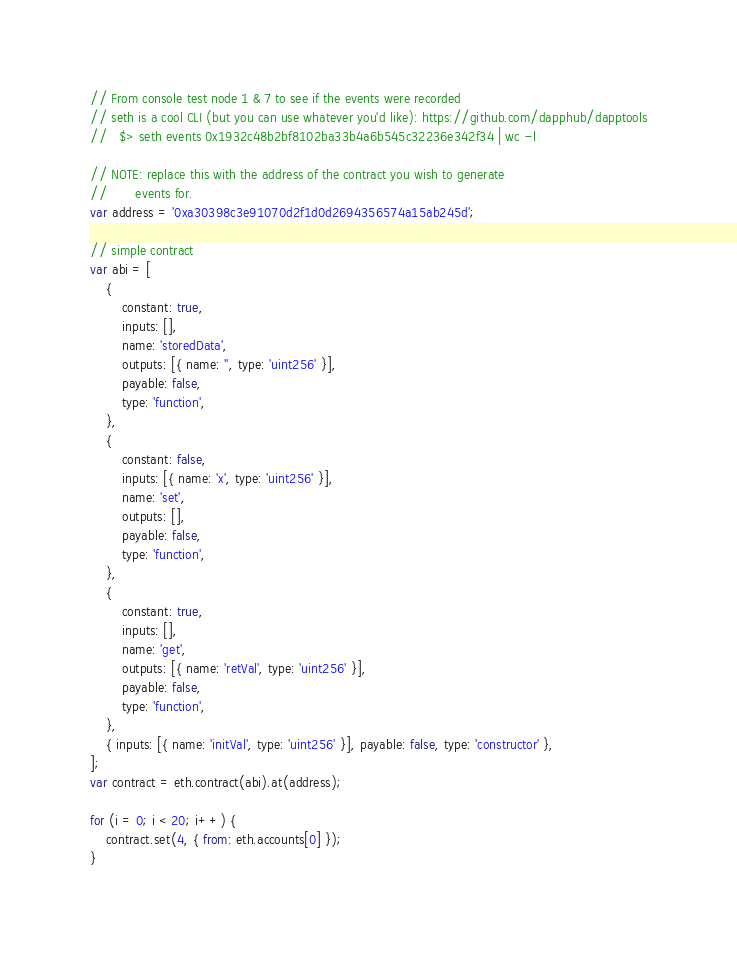Convert code to text. <code><loc_0><loc_0><loc_500><loc_500><_JavaScript_>// From console test node 1 & 7 to see if the events were recorded
// seth is a cool CLI (but you can use whatever you'd like): https://github.com/dapphub/dapptools
//   $> seth events 0x1932c48b2bf8102ba33b4a6b545c32236e342f34 | wc -l

// NOTE: replace this with the address of the contract you wish to generate
//       events for.
var address = '0xa30398c3e91070d2f1d0d2694356574a15ab245d';

// simple contract
var abi = [
    {
        constant: true,
        inputs: [],
        name: 'storedData',
        outputs: [{ name: '', type: 'uint256' }],
        payable: false,
        type: 'function',
    },
    {
        constant: false,
        inputs: [{ name: 'x', type: 'uint256' }],
        name: 'set',
        outputs: [],
        payable: false,
        type: 'function',
    },
    {
        constant: true,
        inputs: [],
        name: 'get',
        outputs: [{ name: 'retVal', type: 'uint256' }],
        payable: false,
        type: 'function',
    },
    { inputs: [{ name: 'initVal', type: 'uint256' }], payable: false, type: 'constructor' },
];
var contract = eth.contract(abi).at(address);

for (i = 0; i < 20; i++) {
    contract.set(4, { from: eth.accounts[0] });
}
</code> 